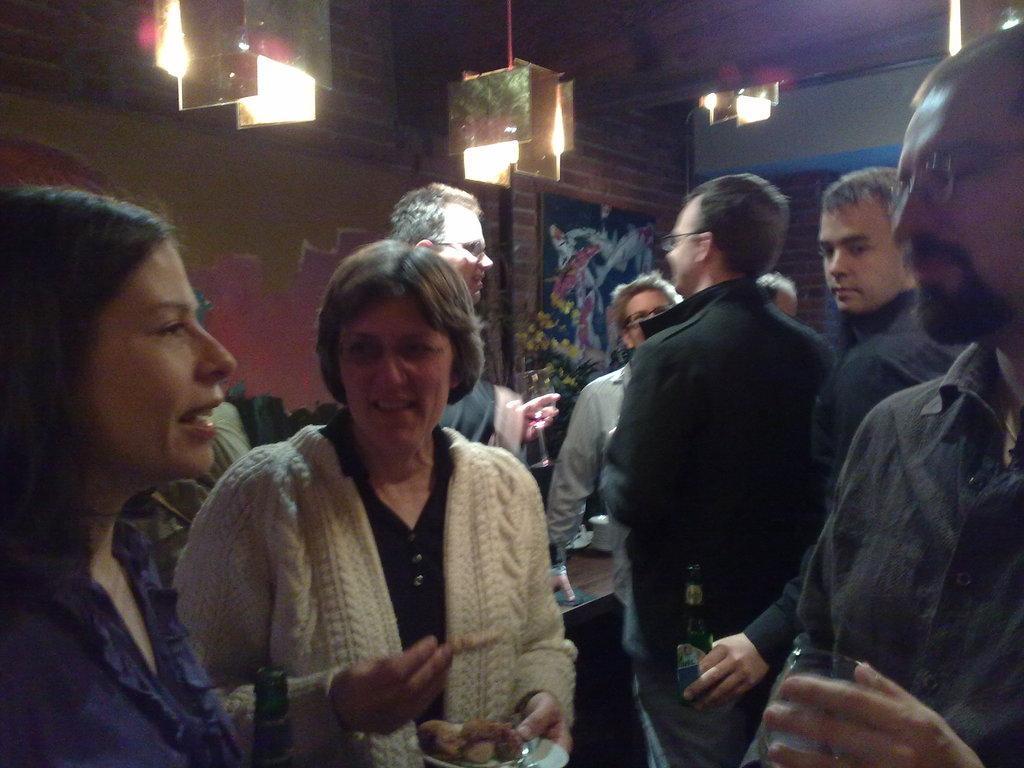Describe this image in one or two sentences. There is a party going inside a room,all the people are drinking and having some food and in the background there is a brick wall. There is a poster attached to the brick wall and there are beautiful light and down from the roof. 